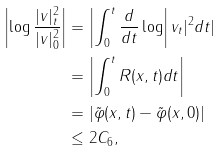Convert formula to latex. <formula><loc_0><loc_0><loc_500><loc_500>\left | \log \frac { | v | ^ { 2 } _ { t } } { | v | ^ { 2 } _ { 0 } } \right | & = \left | \int _ { 0 } ^ { t } \frac { d } { d t } \log \right | v _ { t } | ^ { 2 } d t | \\ & = \left | \int _ { 0 } ^ { t } R ( x , t ) d t \right | \\ & = \left | \tilde { \varphi } ( x , t ) - \tilde { \varphi } ( x , 0 ) \right | \\ & \leq 2 C _ { 6 } ,</formula> 